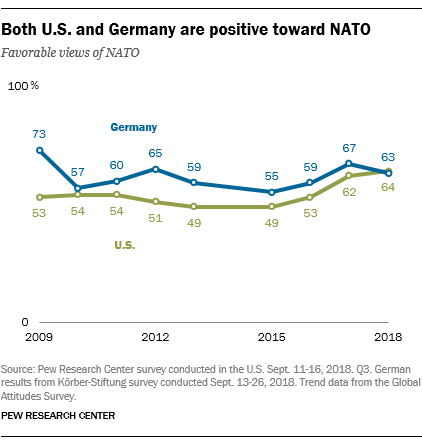Identify some key points in this picture. The rightmost value of the green graph is 64. To determine the result of adding two rightmost values of a blue graph and multiplying the sum by 3, we took the values of the blue graph and added the two rightmost values. We then multiplied the resulting sum by 3 to obtain the final result, which was found to be 390. 